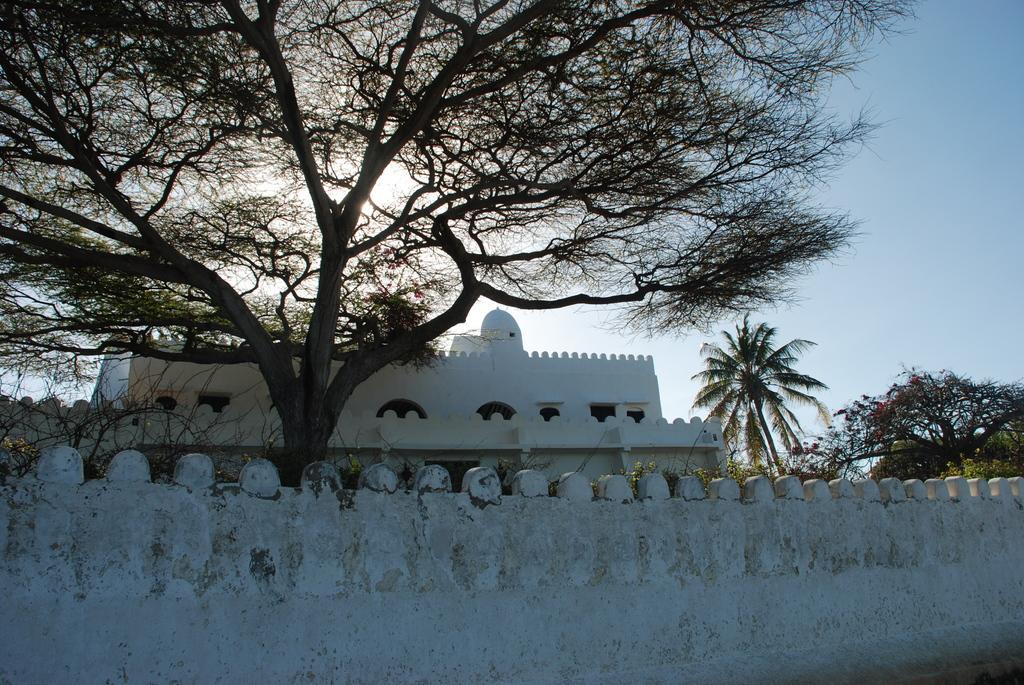Please provide a concise description of this image. In the image there is a wall and behind the wall there are trees and there is a building in between the trees. 